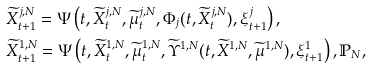Convert formula to latex. <formula><loc_0><loc_0><loc_500><loc_500>& \widetilde { X } ^ { j , N } _ { t + 1 } = \Psi \left ( t , \widetilde { X } ^ { j , N } _ { t } , \widetilde { \mu } ^ { j , N } _ { t } , \Phi _ { j } ( t , \widetilde { X } ^ { j , N } _ { t } ) , \xi ^ { j } _ { t + 1 } \right ) , \\ & \widetilde { X } ^ { 1 , N } _ { t + 1 } = \Psi \left ( t , \widetilde { X } ^ { 1 , N } _ { t } , \widetilde { \mu } ^ { 1 , N } _ { t } , \widetilde { \Upsilon } ^ { 1 , N } ( t , \widetilde { X } ^ { 1 , N } , \widetilde { \mu } ^ { 1 , N } ) , \xi ^ { 1 } _ { t + 1 } \right ) , \mathbb { P } _ { N } ,</formula> 